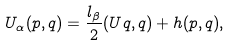<formula> <loc_0><loc_0><loc_500><loc_500>U _ { \alpha } ( p , q ) = \frac { l _ { \beta } } { 2 } ( U q , q ) + h ( p , q ) ,</formula> 